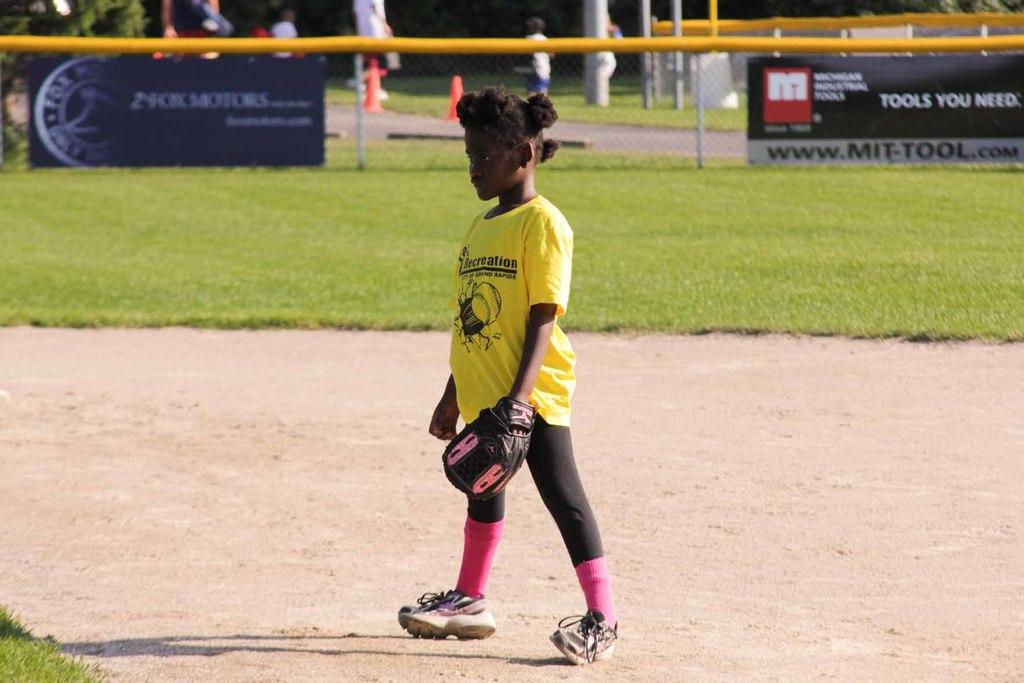What does mit think you need?
Make the answer very short. Unanswerable. What is wrote on the boy shirt?
Make the answer very short. Recreation. 